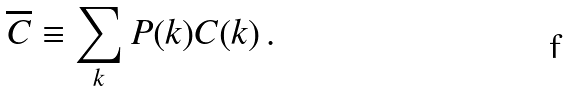<formula> <loc_0><loc_0><loc_500><loc_500>\overline { C } \equiv \sum _ { k } P ( k ) C ( k ) \, .</formula> 